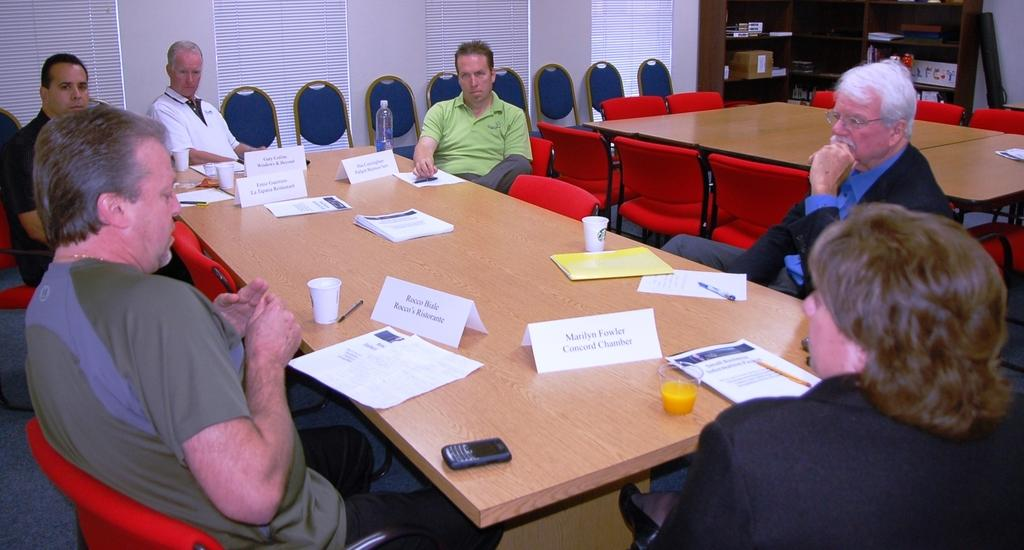What are the people in the image doing? The people in the image are sitting on chairs. What is located in front of the chairs? There is a table in front of the chairs. What can be seen on the table? There are objects placed on the table. How many crates are stacked on the ground in the image? There are no crates present in the image. What type of passenger is sitting on the chair in the image? There is no reference to a passenger in the image; it simply shows people sitting on chairs. 